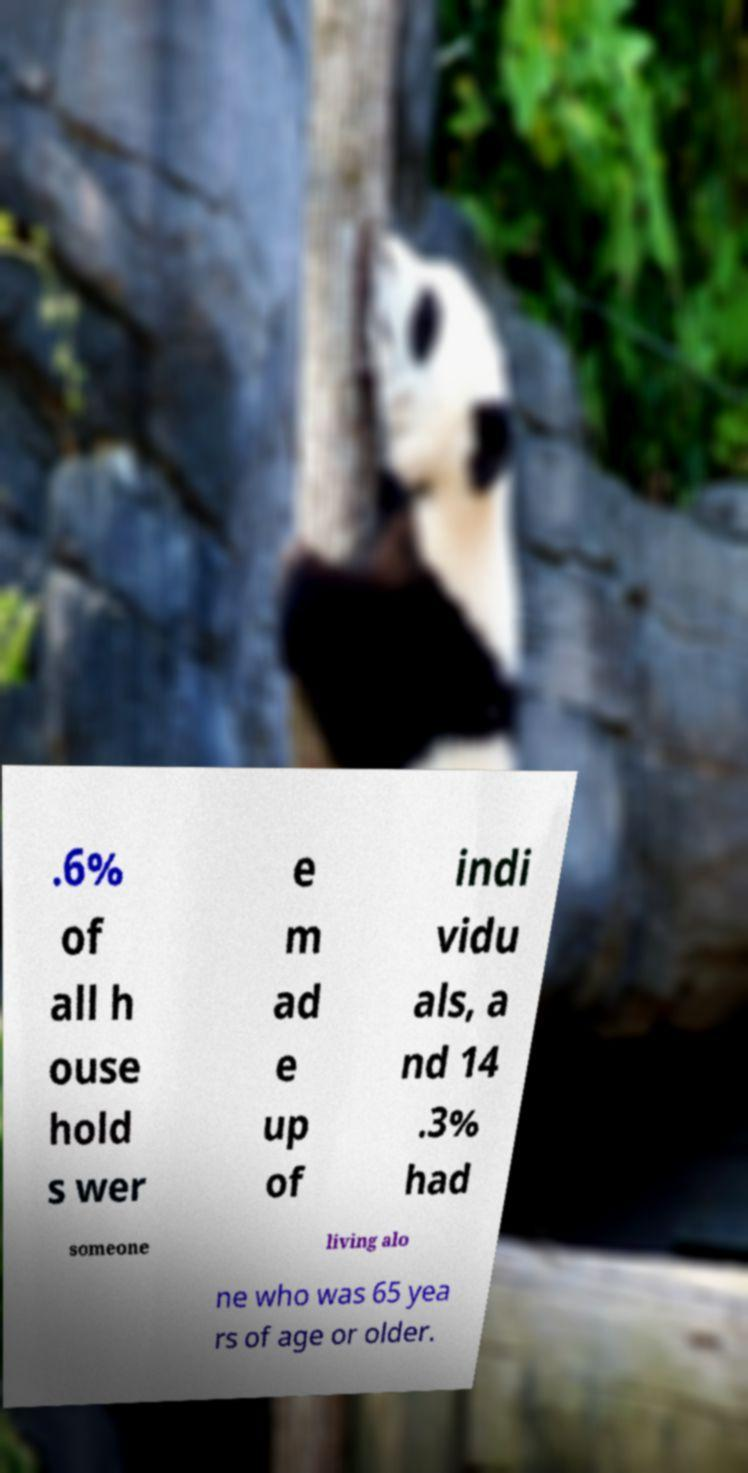For documentation purposes, I need the text within this image transcribed. Could you provide that? .6% of all h ouse hold s wer e m ad e up of indi vidu als, a nd 14 .3% had someone living alo ne who was 65 yea rs of age or older. 